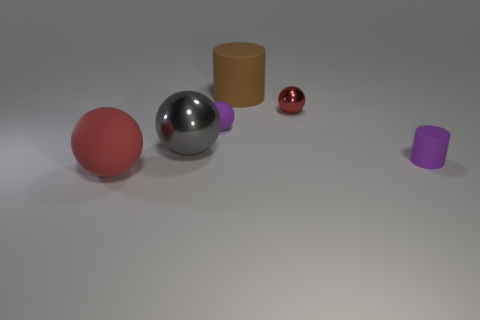Can you describe the lighting condition in the scene? The image features soft, diffused lighting, likely from an overhead source, giving the objects a gentle set of shadows and a realistic look. This type of lighting minimizes harsh shadows and highlights, allowing for clear visibility of object colors and textures. 